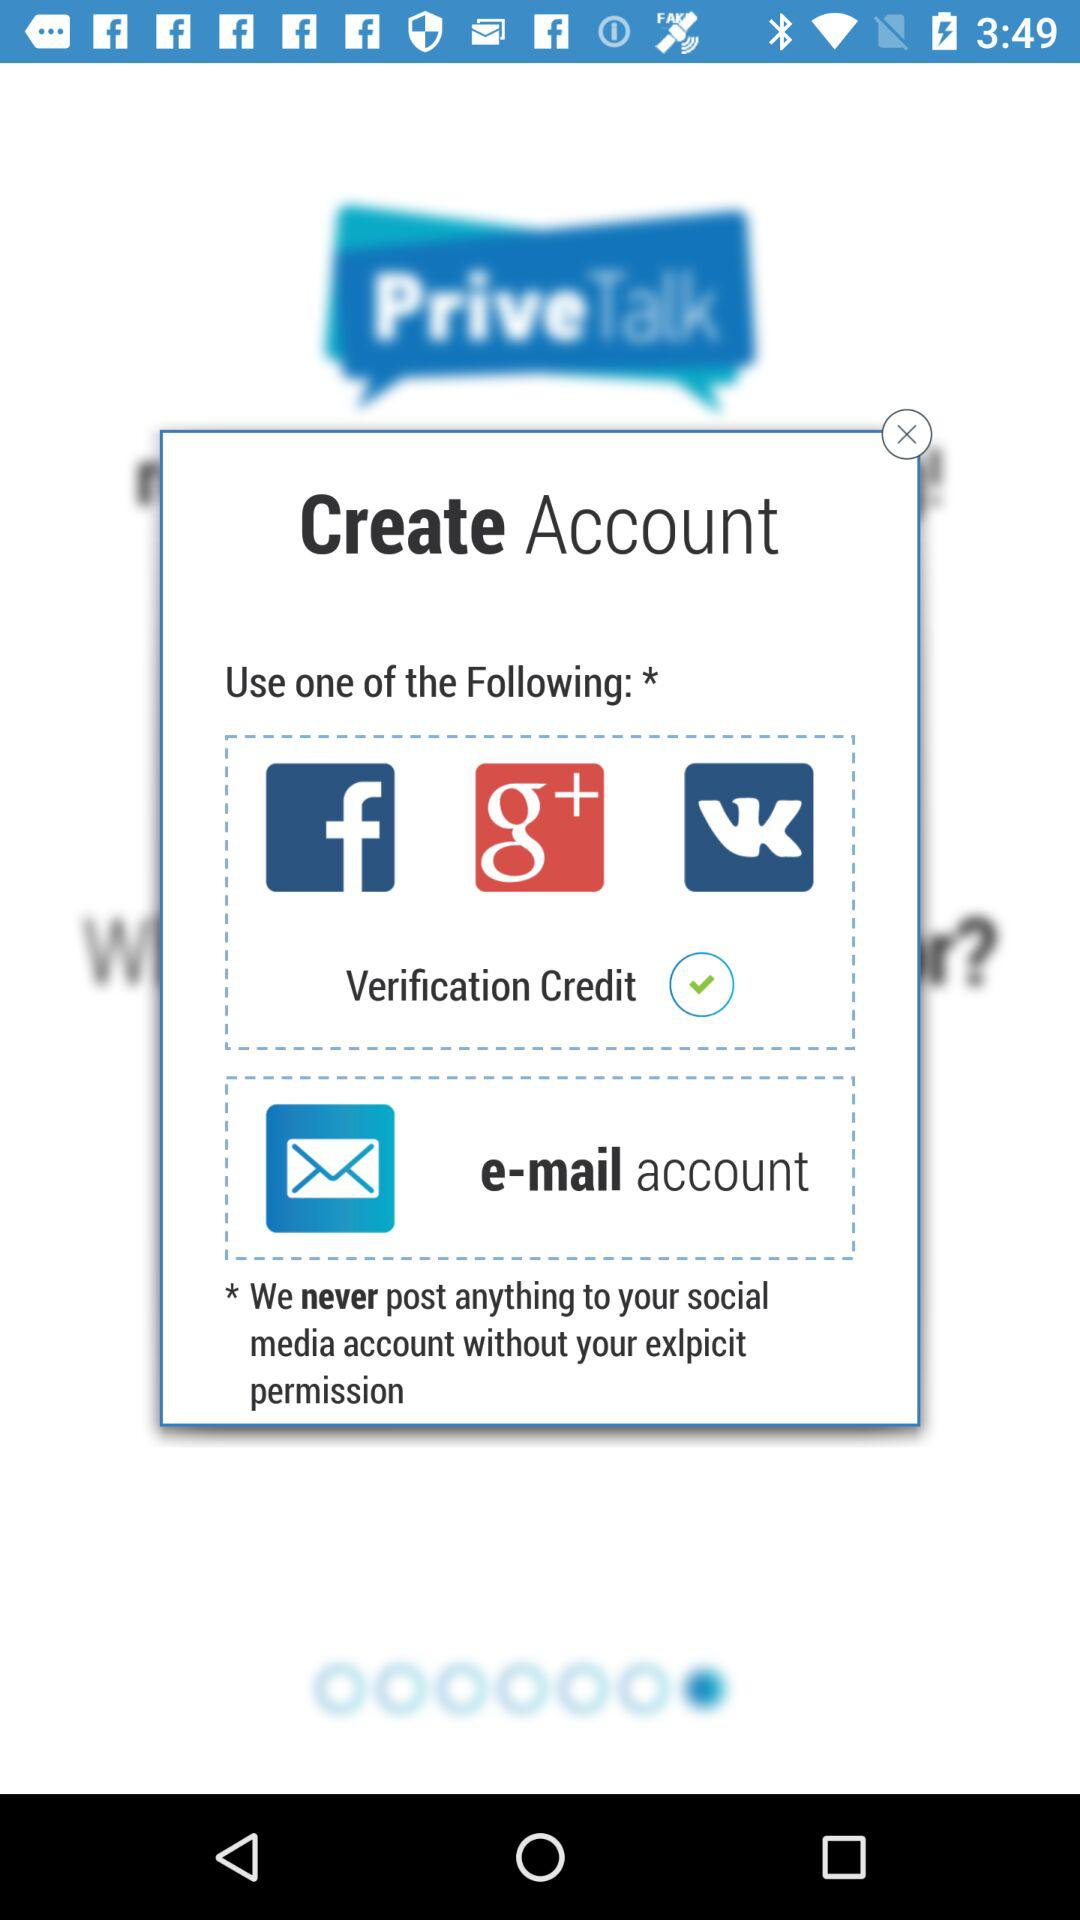What are the options through which we can create an account? The options are "Facebook", "Google+", "VKontakte" and "e-mail". 